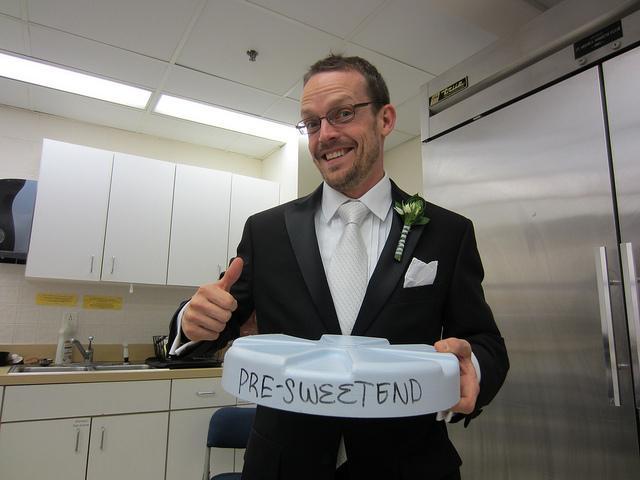How many screws do you see?
Give a very brief answer. 0. How many people can you see?
Give a very brief answer. 1. 